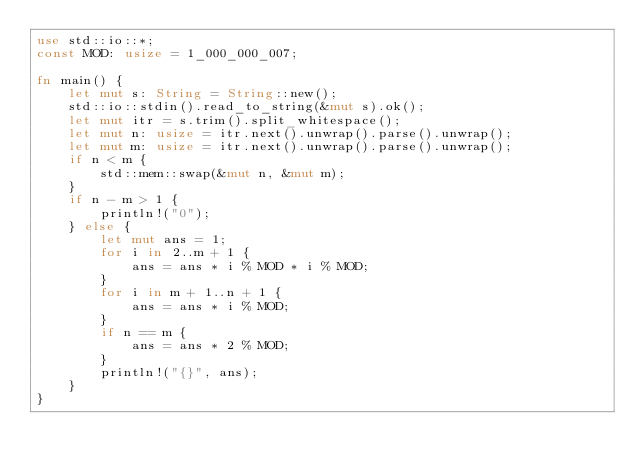Convert code to text. <code><loc_0><loc_0><loc_500><loc_500><_Rust_>use std::io::*;
const MOD: usize = 1_000_000_007;

fn main() {
    let mut s: String = String::new();
    std::io::stdin().read_to_string(&mut s).ok();
    let mut itr = s.trim().split_whitespace();
    let mut n: usize = itr.next().unwrap().parse().unwrap();
    let mut m: usize = itr.next().unwrap().parse().unwrap();
    if n < m {
        std::mem::swap(&mut n, &mut m);
    }
    if n - m > 1 {
        println!("0");
    } else {
        let mut ans = 1;
        for i in 2..m + 1 {
            ans = ans * i % MOD * i % MOD;
        }
        for i in m + 1..n + 1 {
            ans = ans * i % MOD;
        }
        if n == m {
            ans = ans * 2 % MOD;
        }
        println!("{}", ans);
    }
}
</code> 